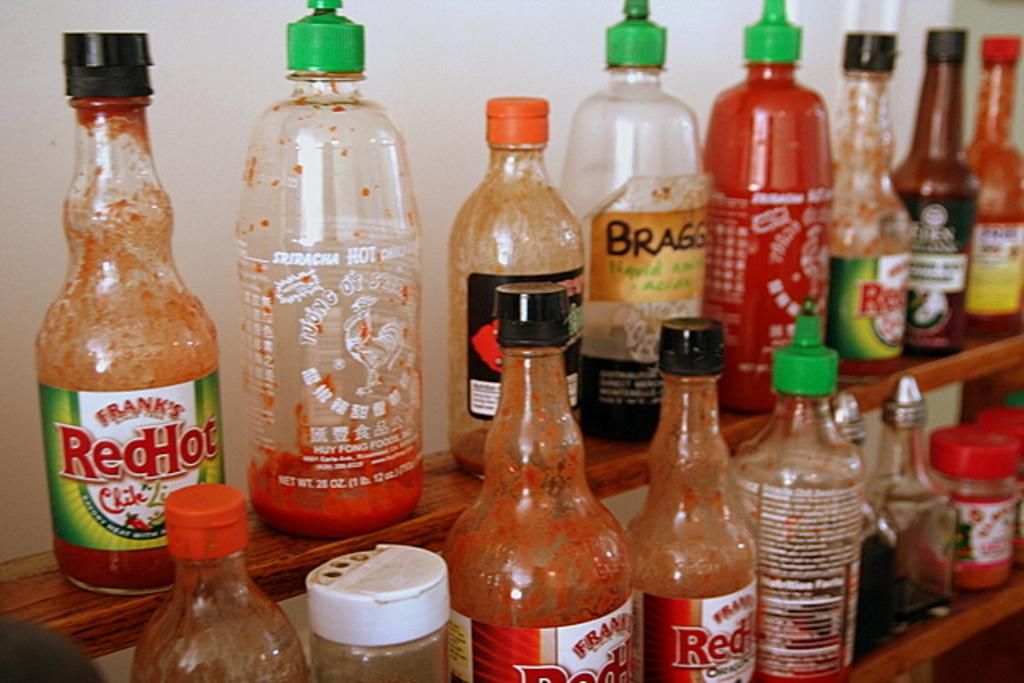<image>
Render a clear and concise summary of the photo. A shelf with two rows of hot sauce, including Frank's Red Hot and Sriracha Sauce, with most of the bottles nearly empty. 